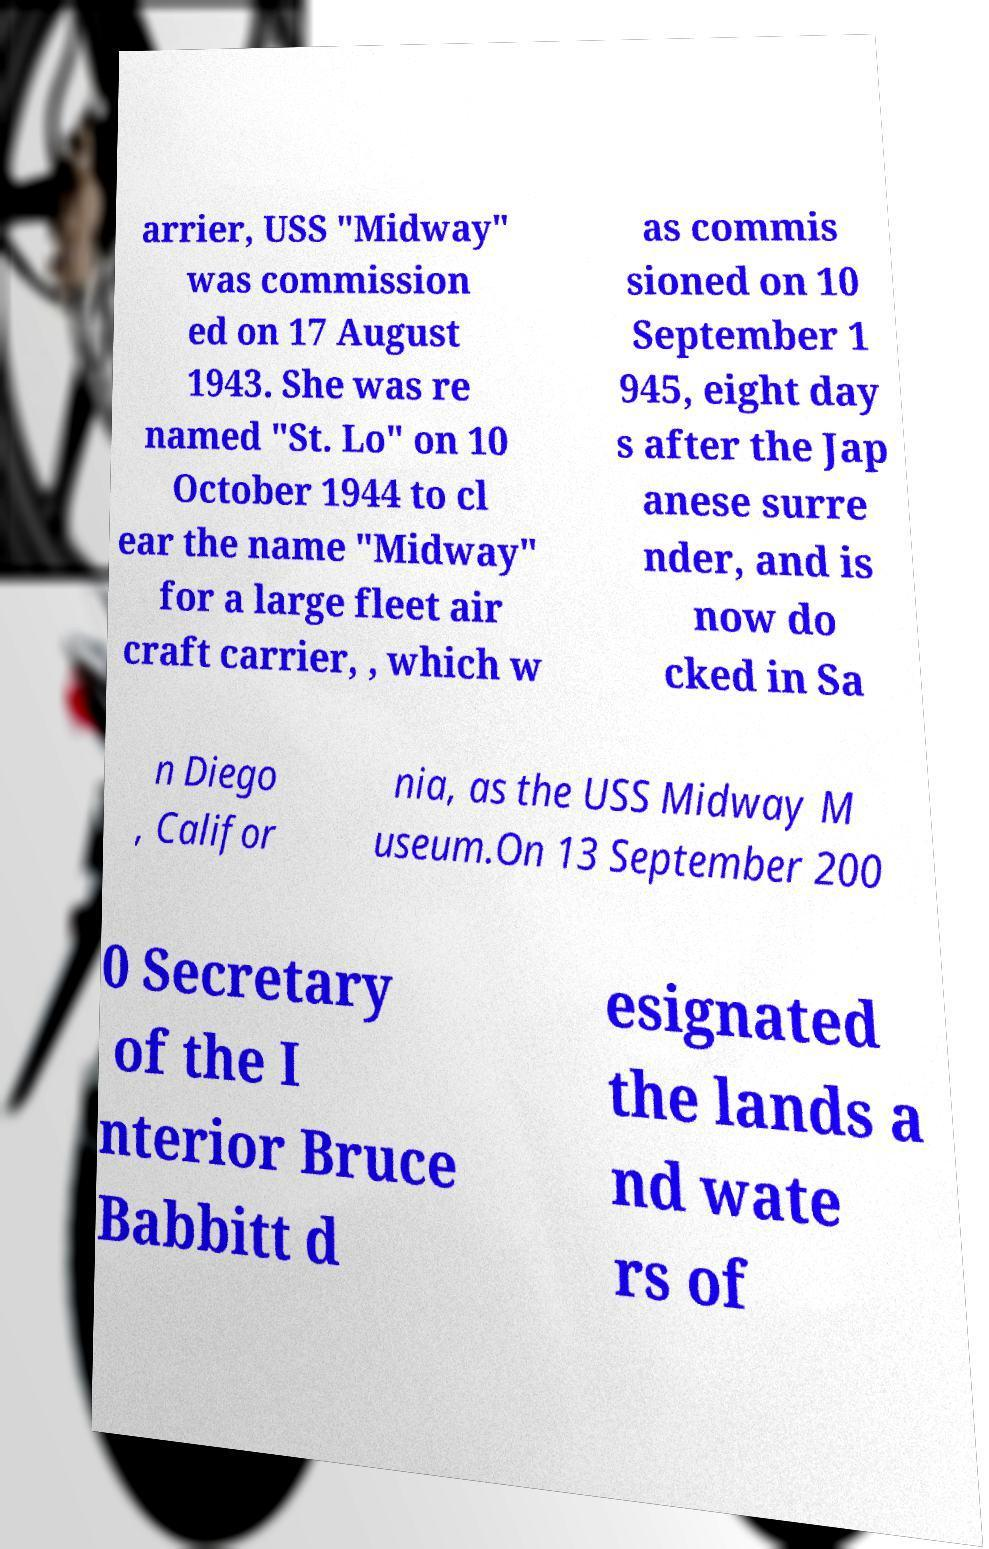There's text embedded in this image that I need extracted. Can you transcribe it verbatim? arrier, USS "Midway" was commission ed on 17 August 1943. She was re named "St. Lo" on 10 October 1944 to cl ear the name "Midway" for a large fleet air craft carrier, , which w as commis sioned on 10 September 1 945, eight day s after the Jap anese surre nder, and is now do cked in Sa n Diego , Califor nia, as the USS Midway M useum.On 13 September 200 0 Secretary of the I nterior Bruce Babbitt d esignated the lands a nd wate rs of 